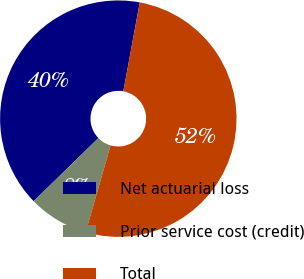<chart> <loc_0><loc_0><loc_500><loc_500><pie_chart><fcel>Net actuarial loss<fcel>Prior service cost (credit)<fcel>Total<nl><fcel>40.21%<fcel>8.25%<fcel>51.55%<nl></chart> 